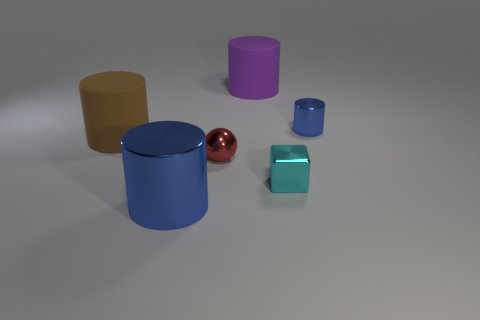What size is the other blue shiny object that is the same shape as the large blue shiny thing?
Provide a short and direct response. Small. The small shiny thing left of the big thing that is on the right side of the large blue cylinder is what shape?
Offer a terse response. Sphere. Is there any other thing that has the same size as the purple cylinder?
Provide a succinct answer. Yes. What shape is the red shiny thing to the left of the metallic cylinder to the right of the large cylinder that is to the right of the red sphere?
Your response must be concise. Sphere. What number of things are either blue metallic objects that are left of the cyan metallic cube or large cylinders that are on the right side of the small red thing?
Keep it short and to the point. 2. There is a brown thing; is it the same size as the thing that is in front of the cyan cube?
Your response must be concise. Yes. Are the blue thing on the left side of the small cyan thing and the small red object behind the small cyan object made of the same material?
Make the answer very short. Yes. Is the number of small metallic spheres behind the brown matte cylinder the same as the number of tiny blue metal cylinders that are on the right side of the cyan metallic object?
Give a very brief answer. No. What number of metallic objects are the same color as the big metal cylinder?
Your response must be concise. 1. What is the material of the large thing that is the same color as the small cylinder?
Provide a short and direct response. Metal. 